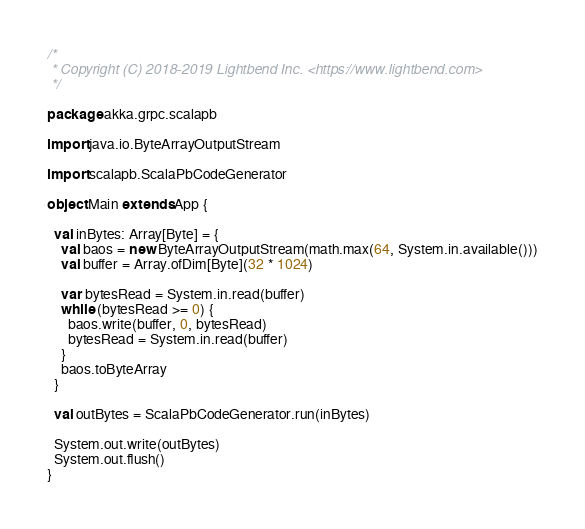<code> <loc_0><loc_0><loc_500><loc_500><_Scala_>/*
 * Copyright (C) 2018-2019 Lightbend Inc. <https://www.lightbend.com>
 */

package akka.grpc.scalapb

import java.io.ByteArrayOutputStream

import scalapb.ScalaPbCodeGenerator

object Main extends App {

  val inBytes: Array[Byte] = {
    val baos = new ByteArrayOutputStream(math.max(64, System.in.available()))
    val buffer = Array.ofDim[Byte](32 * 1024)

    var bytesRead = System.in.read(buffer)
    while (bytesRead >= 0) {
      baos.write(buffer, 0, bytesRead)
      bytesRead = System.in.read(buffer)
    }
    baos.toByteArray
  }

  val outBytes = ScalaPbCodeGenerator.run(inBytes)

  System.out.write(outBytes)
  System.out.flush()
}
</code> 